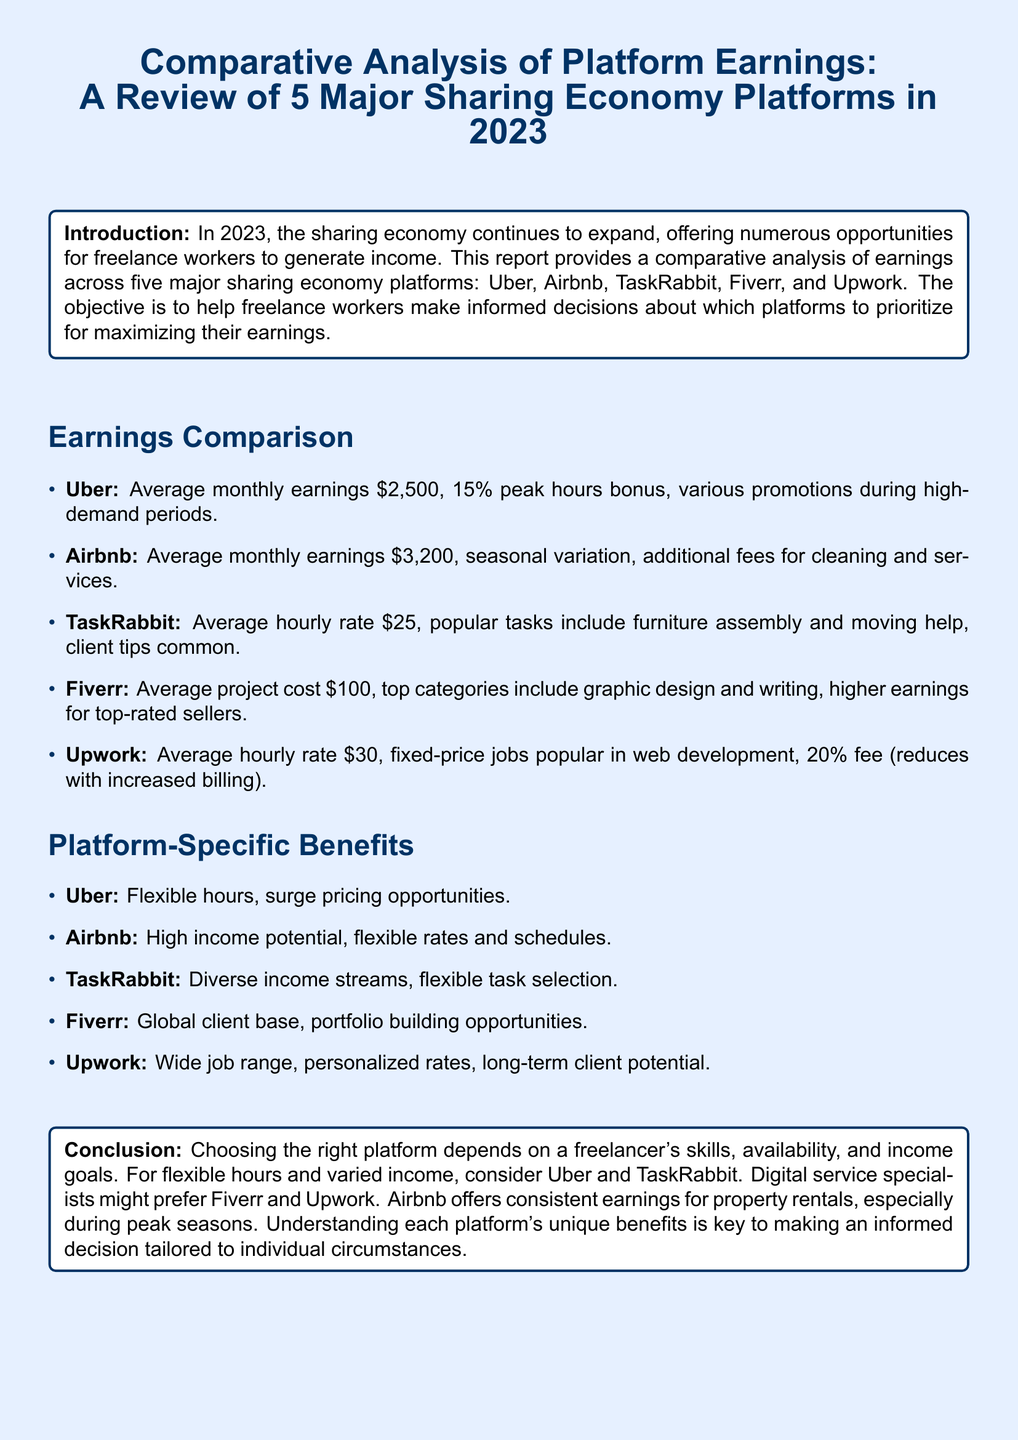What are the average monthly earnings for Uber? The average monthly earnings for Uber is stated in the "Earnings Comparison" section as \$2,500.
Answer: $2,500 What is the average project cost on Fiverr? The average project cost for Fiverr is mentioned as \$100 in the "Earnings Comparison" section.
Answer: $100 What is the peak hours bonus percentage for Uber drivers? The document specifies that Uber offers a 15% peak hours bonus.
Answer: 15% Which platform offers a high income potential with flexible rates and schedules? The document indicates that Airbnb offers a high income potential with flexible rates and schedules.
Answer: Airbnb What is the average hourly rate on Upwork? Upwork's average hourly rate is provided as \$30 in the "Earnings Comparison" section.
Answer: $30 Which platform allows for diverse income streams and flexible task selection? The document states that TaskRabbit allows for diverse income streams and flexible task selection.
Answer: TaskRabbit What is the fee percentage on fixed-price jobs for Upwork? The document notes that Upwork has a fee of 20% on fixed-price jobs.
Answer: 20% What type of workers might prefer Fiverr and Upwork? The document suggests that digital service specialists might prefer Fiverr and Upwork.
Answer: Digital service specialists What is the main conclusion about choosing the right platform? The conclusion emphasizes that choosing the right platform depends on a freelancer's skills, availability, and income goals.
Answer: Skills, availability, and income goals 